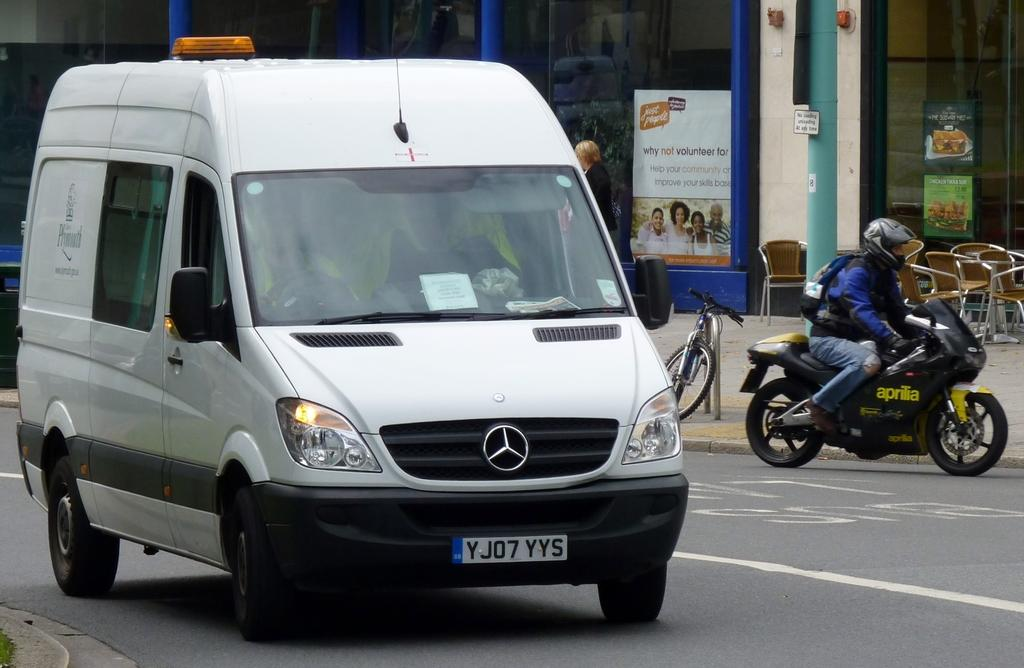Provide a one-sentence caption for the provided image. A Mercedes van with license plate YJ07YYS drives down the street. 